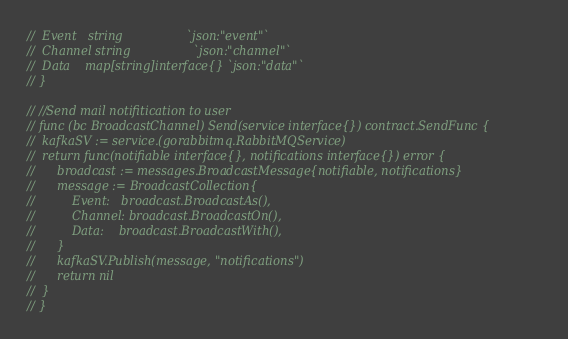Convert code to text. <code><loc_0><loc_0><loc_500><loc_500><_Go_>// 	Event   string                 `json:"event"`
// 	Channel string                 `json:"channel"`
// 	Data    map[string]interface{} `json:"data"`
// }

// //Send mail notifitication to user
// func (bc BroadcastChannel) Send(service interface{}) contract.SendFunc {
// 	kafkaSV := service.(gorabbitmq.RabbitMQService)
// 	return func(notifiable interface{}, notifications interface{}) error {
// 		broadcast := messages.BroadcastMessage{notifiable, notifications}
// 		message := BroadcastCollection{
// 			Event:   broadcast.BroadcastAs(),
// 			Channel: broadcast.BroadcastOn(),
// 			Data:    broadcast.BroadcastWith(),
// 		}
// 		kafkaSV.Publish(message, "notifications")
// 		return nil
// 	}
// }
</code> 